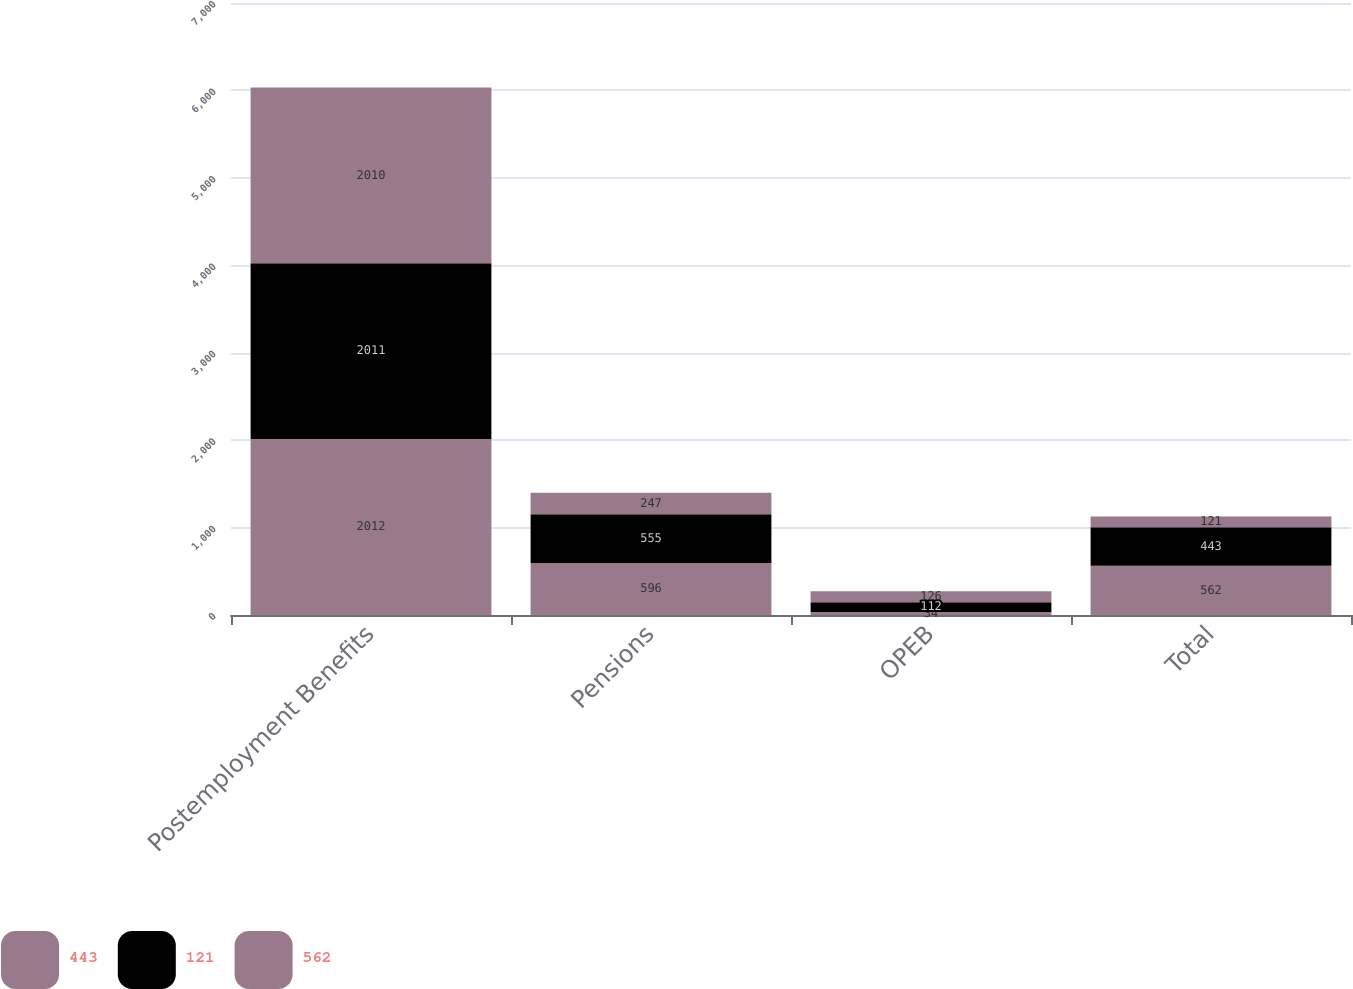Convert chart to OTSL. <chart><loc_0><loc_0><loc_500><loc_500><stacked_bar_chart><ecel><fcel>Postemployment Benefits<fcel>Pensions<fcel>OPEB<fcel>Total<nl><fcel>443<fcel>2012<fcel>596<fcel>34<fcel>562<nl><fcel>121<fcel>2011<fcel>555<fcel>112<fcel>443<nl><fcel>562<fcel>2010<fcel>247<fcel>126<fcel>121<nl></chart> 